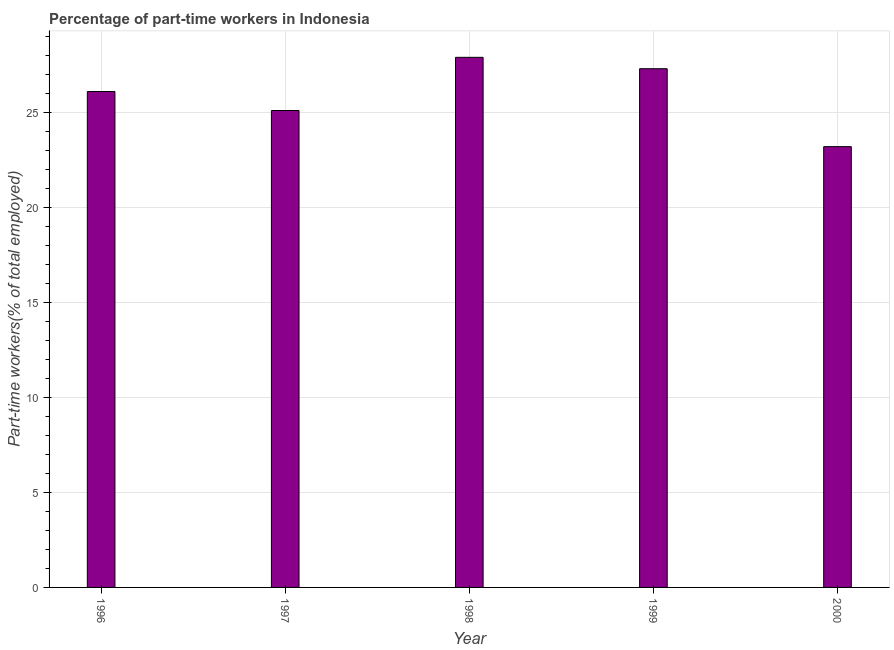Does the graph contain any zero values?
Your answer should be compact. No. What is the title of the graph?
Offer a very short reply. Percentage of part-time workers in Indonesia. What is the label or title of the X-axis?
Provide a short and direct response. Year. What is the label or title of the Y-axis?
Ensure brevity in your answer.  Part-time workers(% of total employed). What is the percentage of part-time workers in 1996?
Offer a terse response. 26.1. Across all years, what is the maximum percentage of part-time workers?
Your answer should be compact. 27.9. Across all years, what is the minimum percentage of part-time workers?
Offer a terse response. 23.2. In which year was the percentage of part-time workers minimum?
Your answer should be very brief. 2000. What is the sum of the percentage of part-time workers?
Keep it short and to the point. 129.6. What is the difference between the percentage of part-time workers in 1996 and 1998?
Offer a very short reply. -1.8. What is the average percentage of part-time workers per year?
Provide a succinct answer. 25.92. What is the median percentage of part-time workers?
Give a very brief answer. 26.1. In how many years, is the percentage of part-time workers greater than 14 %?
Provide a succinct answer. 5. What is the ratio of the percentage of part-time workers in 1997 to that in 1998?
Give a very brief answer. 0.9. Is the percentage of part-time workers in 1996 less than that in 1999?
Provide a succinct answer. Yes. What is the difference between the highest and the second highest percentage of part-time workers?
Make the answer very short. 0.6. What is the difference between the highest and the lowest percentage of part-time workers?
Make the answer very short. 4.7. In how many years, is the percentage of part-time workers greater than the average percentage of part-time workers taken over all years?
Provide a short and direct response. 3. How many bars are there?
Give a very brief answer. 5. Are all the bars in the graph horizontal?
Provide a succinct answer. No. How many years are there in the graph?
Your answer should be compact. 5. What is the Part-time workers(% of total employed) in 1996?
Your answer should be compact. 26.1. What is the Part-time workers(% of total employed) of 1997?
Offer a very short reply. 25.1. What is the Part-time workers(% of total employed) in 1998?
Offer a terse response. 27.9. What is the Part-time workers(% of total employed) in 1999?
Your answer should be very brief. 27.3. What is the Part-time workers(% of total employed) in 2000?
Give a very brief answer. 23.2. What is the difference between the Part-time workers(% of total employed) in 1996 and 1998?
Ensure brevity in your answer.  -1.8. What is the difference between the Part-time workers(% of total employed) in 1996 and 1999?
Make the answer very short. -1.2. What is the difference between the Part-time workers(% of total employed) in 1996 and 2000?
Provide a short and direct response. 2.9. What is the difference between the Part-time workers(% of total employed) in 1998 and 1999?
Make the answer very short. 0.6. What is the difference between the Part-time workers(% of total employed) in 1998 and 2000?
Give a very brief answer. 4.7. What is the ratio of the Part-time workers(% of total employed) in 1996 to that in 1998?
Make the answer very short. 0.94. What is the ratio of the Part-time workers(% of total employed) in 1996 to that in 1999?
Your answer should be compact. 0.96. What is the ratio of the Part-time workers(% of total employed) in 1997 to that in 1999?
Keep it short and to the point. 0.92. What is the ratio of the Part-time workers(% of total employed) in 1997 to that in 2000?
Provide a short and direct response. 1.08. What is the ratio of the Part-time workers(% of total employed) in 1998 to that in 2000?
Your answer should be very brief. 1.2. What is the ratio of the Part-time workers(% of total employed) in 1999 to that in 2000?
Your answer should be very brief. 1.18. 